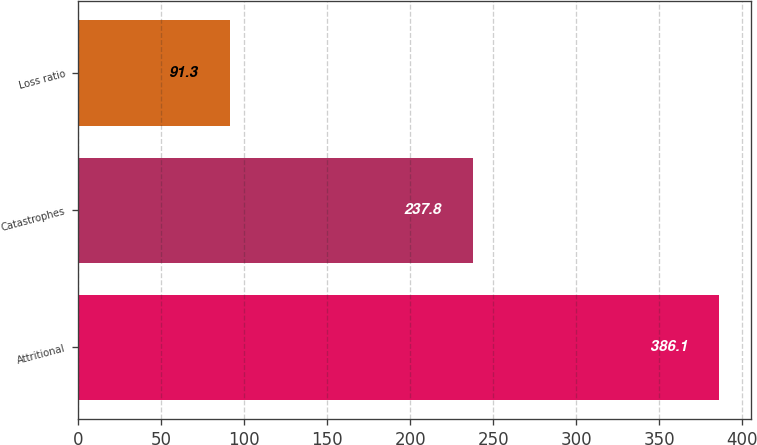Convert chart. <chart><loc_0><loc_0><loc_500><loc_500><bar_chart><fcel>Attritional<fcel>Catastrophes<fcel>Loss ratio<nl><fcel>386.1<fcel>237.8<fcel>91.3<nl></chart> 